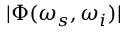Convert formula to latex. <formula><loc_0><loc_0><loc_500><loc_500>| \Phi ( \omega _ { s } , \omega _ { i } ) |</formula> 